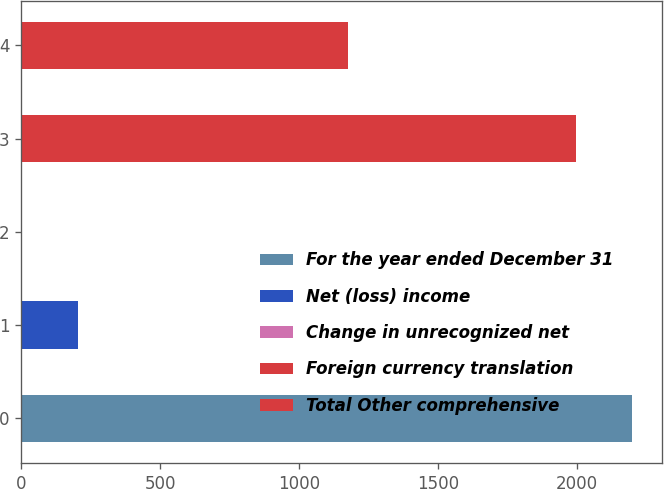<chart> <loc_0><loc_0><loc_500><loc_500><bar_chart><fcel>For the year ended December 31<fcel>Net (loss) income<fcel>Change in unrecognized net<fcel>Foreign currency translation<fcel>Total Other comprehensive<nl><fcel>2196.3<fcel>203.3<fcel>2<fcel>1995<fcel>1176<nl></chart> 